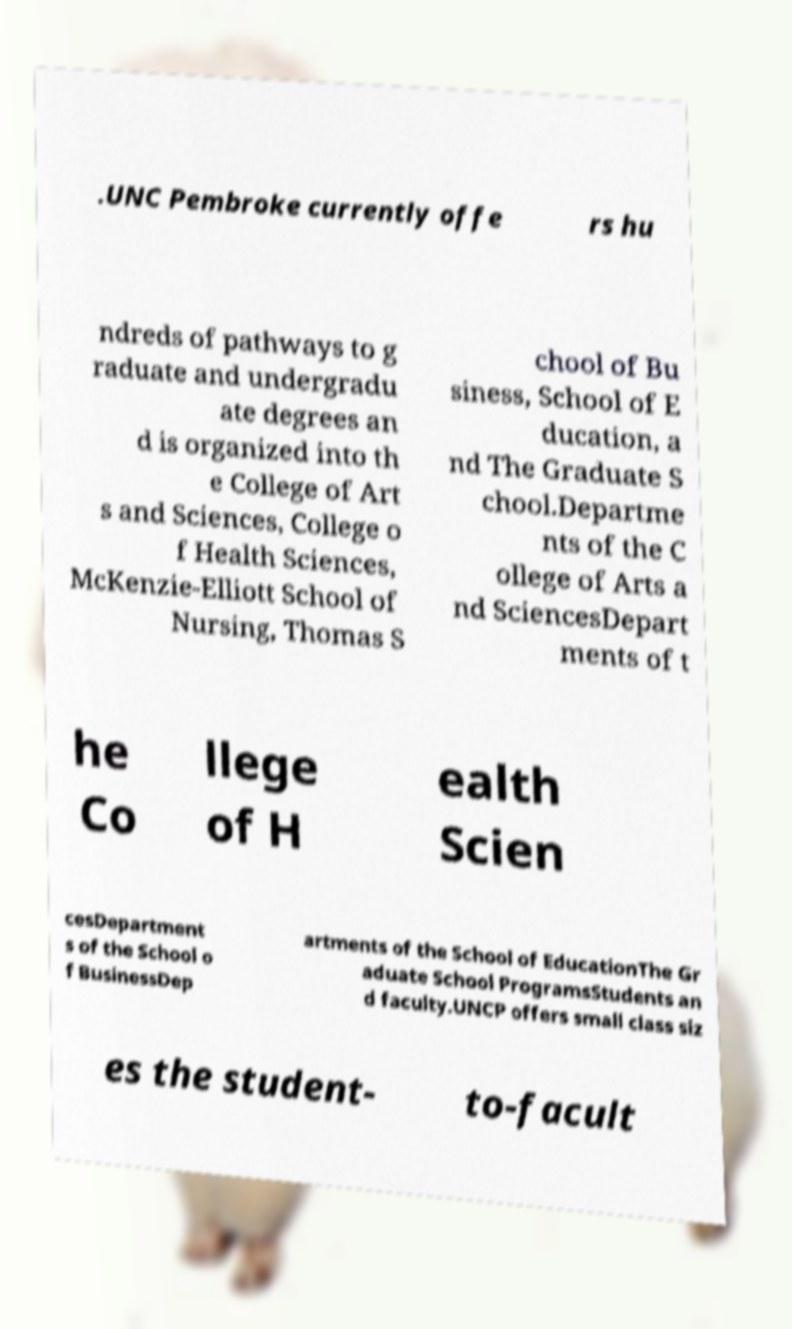I need the written content from this picture converted into text. Can you do that? .UNC Pembroke currently offe rs hu ndreds of pathways to g raduate and undergradu ate degrees an d is organized into th e College of Art s and Sciences, College o f Health Sciences, McKenzie-Elliott School of Nursing, Thomas S chool of Bu siness, School of E ducation, a nd The Graduate S chool.Departme nts of the C ollege of Arts a nd SciencesDepart ments of t he Co llege of H ealth Scien cesDepartment s of the School o f BusinessDep artments of the School of EducationThe Gr aduate School ProgramsStudents an d faculty.UNCP offers small class siz es the student- to-facult 